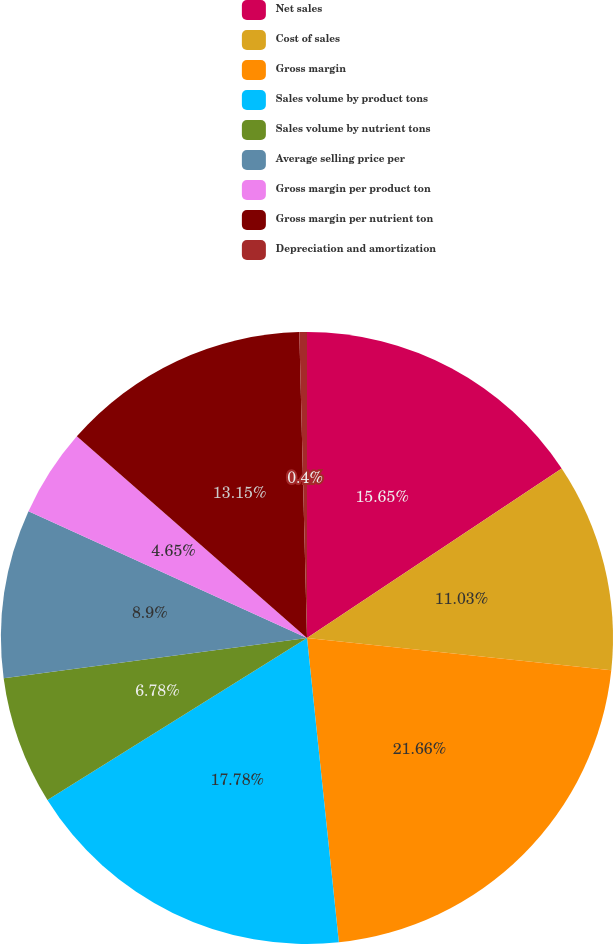<chart> <loc_0><loc_0><loc_500><loc_500><pie_chart><fcel>Net sales<fcel>Cost of sales<fcel>Gross margin<fcel>Sales volume by product tons<fcel>Sales volume by nutrient tons<fcel>Average selling price per<fcel>Gross margin per product ton<fcel>Gross margin per nutrient ton<fcel>Depreciation and amortization<nl><fcel>15.65%<fcel>11.03%<fcel>21.66%<fcel>17.78%<fcel>6.78%<fcel>8.9%<fcel>4.65%<fcel>13.15%<fcel>0.4%<nl></chart> 